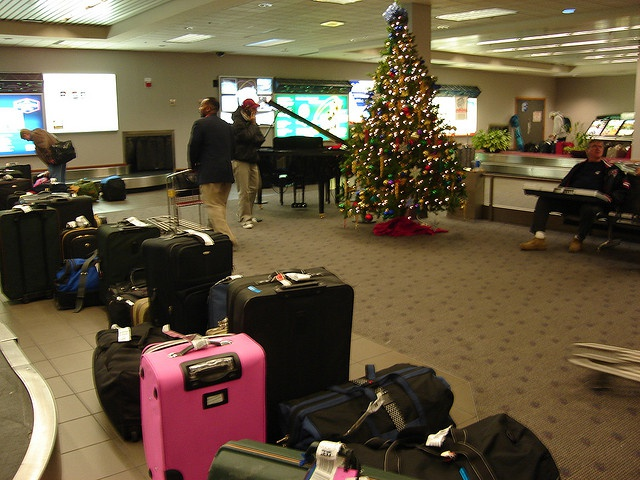Describe the objects in this image and their specific colors. I can see suitcase in beige, brown, salmon, and lightpink tones, suitcase in beige, black, olive, and gray tones, handbag in beige, black, olive, and gray tones, suitcase in beige, black, olive, and tan tones, and suitcase in beige, black, ivory, darkgreen, and gray tones in this image. 